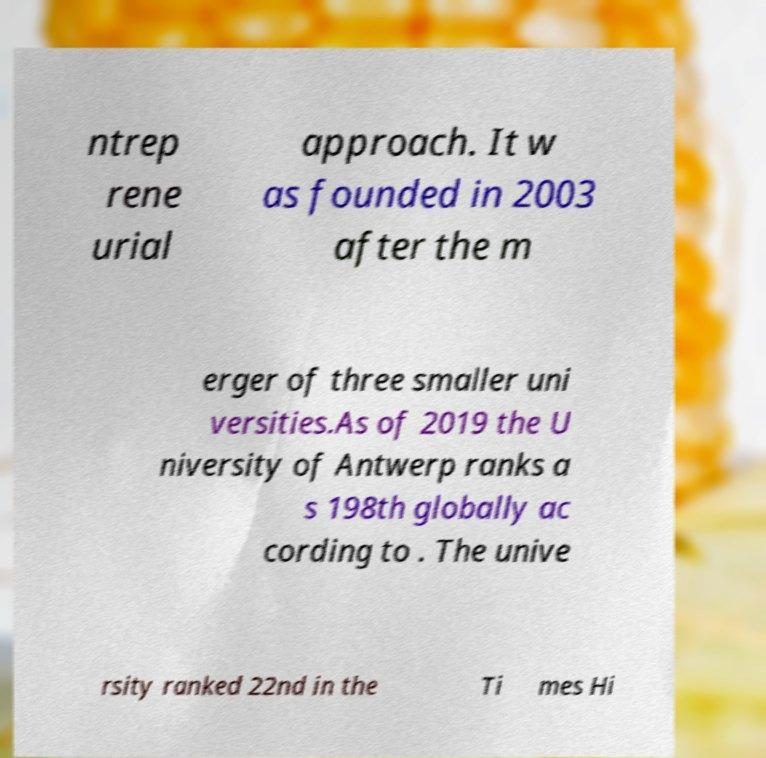Can you accurately transcribe the text from the provided image for me? ntrep rene urial approach. It w as founded in 2003 after the m erger of three smaller uni versities.As of 2019 the U niversity of Antwerp ranks a s 198th globally ac cording to . The unive rsity ranked 22nd in the Ti mes Hi 